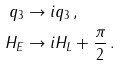Convert formula to latex. <formula><loc_0><loc_0><loc_500><loc_500>q _ { 3 } & \rightarrow i q _ { 3 } \, , \\ H _ { E } & \rightarrow i H _ { L } + \frac { \pi } { 2 } \, .</formula> 